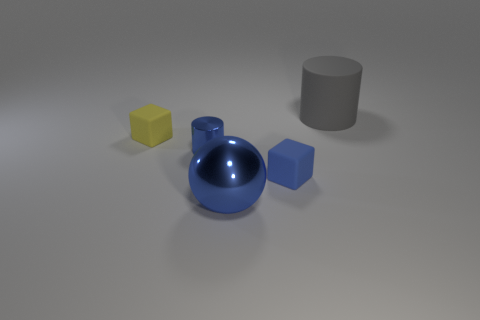What number of things are blocks left of the small blue matte cube or large cyan objects?
Your response must be concise. 1. Is the size of the gray cylinder the same as the blue object that is in front of the tiny blue matte thing?
Make the answer very short. Yes. There is another thing that is the same shape as the tiny blue matte thing; what size is it?
Give a very brief answer. Small. How many tiny yellow matte blocks are in front of the small matte object that is in front of the cube behind the small blue cube?
Give a very brief answer. 0. How many cubes are large green rubber things or tiny blue shiny things?
Offer a very short reply. 0. What is the color of the matte object on the left side of the large blue metal thing that is on the right side of the tiny matte cube that is behind the tiny blue matte thing?
Your answer should be very brief. Yellow. How many other things are the same size as the metallic cylinder?
Provide a short and direct response. 2. Is there anything else that is the same shape as the big blue object?
Provide a succinct answer. No. The other thing that is the same shape as the large gray thing is what color?
Offer a terse response. Blue. The cylinder that is the same material as the small yellow thing is what color?
Offer a terse response. Gray. 